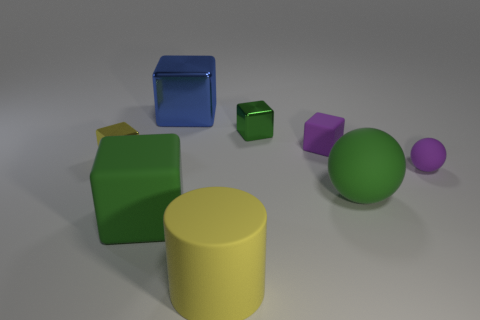Subtract all large blue shiny blocks. How many blocks are left? 4 Add 2 big shiny objects. How many objects exist? 10 Subtract all yellow blocks. How many blocks are left? 4 Subtract all red spheres. Subtract all gray cylinders. How many spheres are left? 2 Add 7 shiny cubes. How many shiny cubes are left? 10 Add 5 red spheres. How many red spheres exist? 5 Subtract 0 brown balls. How many objects are left? 8 Subtract all cylinders. How many objects are left? 7 Subtract 4 blocks. How many blocks are left? 1 Subtract all brown spheres. How many red blocks are left? 0 